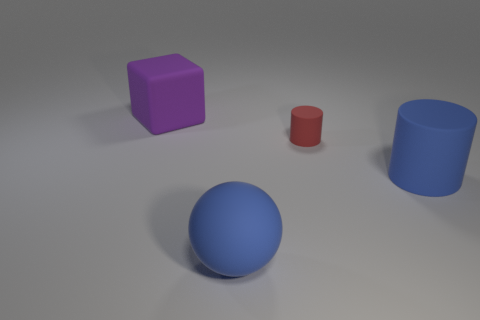Is the big rubber cylinder the same color as the sphere?
Provide a short and direct response. Yes. What material is the cylinder that is left of the big matte object that is to the right of the small matte cylinder?
Give a very brief answer. Rubber. Is there a rubber object that has the same color as the big matte ball?
Your answer should be compact. Yes. There is a matte cylinder that is the same size as the cube; what color is it?
Give a very brief answer. Blue. What material is the large blue sphere to the left of the blue object that is behind the big blue thing to the left of the red matte cylinder?
Offer a terse response. Rubber. There is a big rubber sphere; does it have the same color as the large object that is right of the large sphere?
Offer a terse response. Yes. How many things are big things right of the big blue matte ball or blue rubber things that are left of the red object?
Make the answer very short. 2. What shape is the large rubber object behind the cylinder that is behind the big blue cylinder?
Offer a terse response. Cube. Is there a large yellow cube that has the same material as the blue cylinder?
Your answer should be very brief. No. Are there fewer small red matte things in front of the big blue cylinder than things left of the small thing?
Your response must be concise. Yes. 